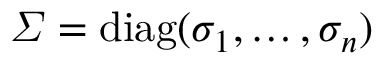<formula> <loc_0><loc_0><loc_500><loc_500>\varSigma = { d i a g } ( \sigma _ { 1 } , \dots , \sigma _ { n } )</formula> 